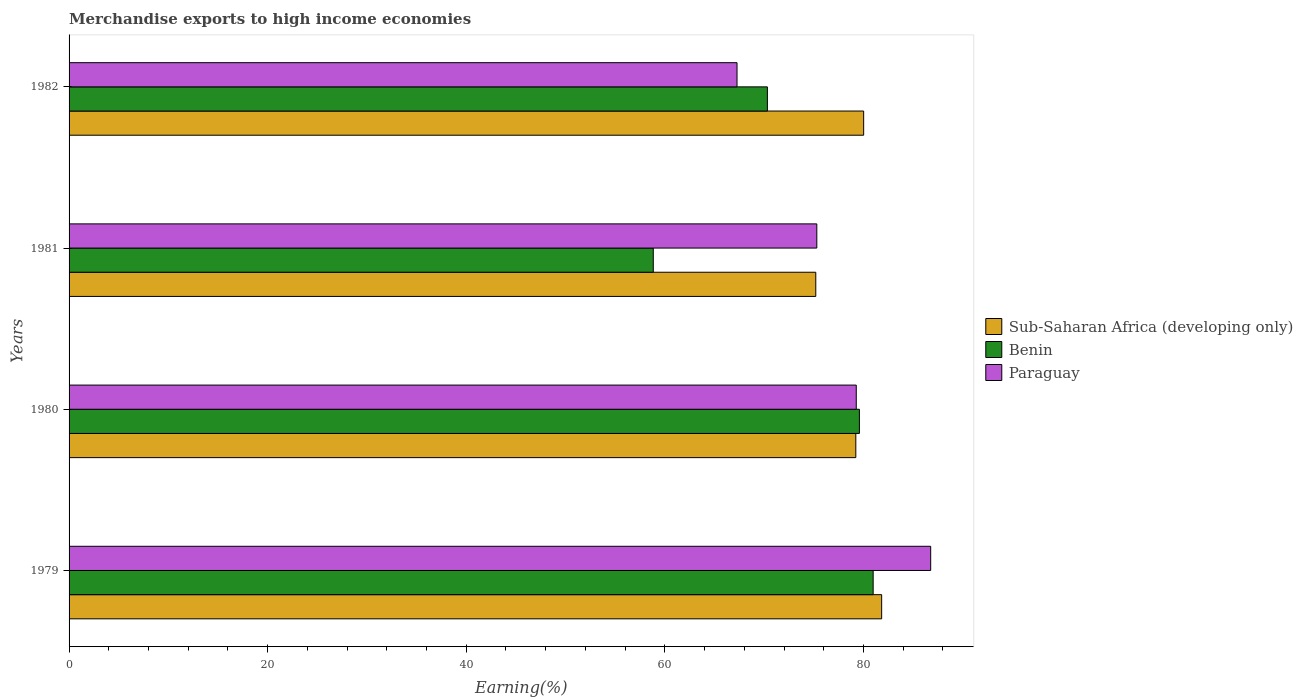Are the number of bars on each tick of the Y-axis equal?
Keep it short and to the point. Yes. How many bars are there on the 3rd tick from the top?
Give a very brief answer. 3. In how many cases, is the number of bars for a given year not equal to the number of legend labels?
Offer a terse response. 0. What is the percentage of amount earned from merchandise exports in Benin in 1982?
Your response must be concise. 70.33. Across all years, what is the maximum percentage of amount earned from merchandise exports in Paraguay?
Provide a short and direct response. 86.77. Across all years, what is the minimum percentage of amount earned from merchandise exports in Paraguay?
Ensure brevity in your answer.  67.27. In which year was the percentage of amount earned from merchandise exports in Sub-Saharan Africa (developing only) maximum?
Your answer should be very brief. 1979. In which year was the percentage of amount earned from merchandise exports in Sub-Saharan Africa (developing only) minimum?
Your response must be concise. 1981. What is the total percentage of amount earned from merchandise exports in Sub-Saharan Africa (developing only) in the graph?
Ensure brevity in your answer.  316.29. What is the difference between the percentage of amount earned from merchandise exports in Paraguay in 1979 and that in 1981?
Offer a terse response. 11.47. What is the difference between the percentage of amount earned from merchandise exports in Paraguay in 1981 and the percentage of amount earned from merchandise exports in Benin in 1982?
Make the answer very short. 4.98. What is the average percentage of amount earned from merchandise exports in Paraguay per year?
Provide a short and direct response. 77.16. In the year 1981, what is the difference between the percentage of amount earned from merchandise exports in Benin and percentage of amount earned from merchandise exports in Sub-Saharan Africa (developing only)?
Provide a short and direct response. -16.37. What is the ratio of the percentage of amount earned from merchandise exports in Paraguay in 1980 to that in 1981?
Your answer should be compact. 1.05. Is the difference between the percentage of amount earned from merchandise exports in Benin in 1979 and 1980 greater than the difference between the percentage of amount earned from merchandise exports in Sub-Saharan Africa (developing only) in 1979 and 1980?
Ensure brevity in your answer.  No. What is the difference between the highest and the second highest percentage of amount earned from merchandise exports in Paraguay?
Offer a terse response. 7.5. What is the difference between the highest and the lowest percentage of amount earned from merchandise exports in Paraguay?
Provide a short and direct response. 19.5. What does the 2nd bar from the top in 1980 represents?
Your response must be concise. Benin. What does the 1st bar from the bottom in 1981 represents?
Your answer should be very brief. Sub-Saharan Africa (developing only). Is it the case that in every year, the sum of the percentage of amount earned from merchandise exports in Paraguay and percentage of amount earned from merchandise exports in Benin is greater than the percentage of amount earned from merchandise exports in Sub-Saharan Africa (developing only)?
Keep it short and to the point. Yes. How many years are there in the graph?
Your answer should be compact. 4. What is the difference between two consecutive major ticks on the X-axis?
Your answer should be very brief. 20. Does the graph contain any zero values?
Keep it short and to the point. No. Where does the legend appear in the graph?
Your response must be concise. Center right. How many legend labels are there?
Ensure brevity in your answer.  3. How are the legend labels stacked?
Your answer should be compact. Vertical. What is the title of the graph?
Provide a short and direct response. Merchandise exports to high income economies. Does "Nepal" appear as one of the legend labels in the graph?
Make the answer very short. No. What is the label or title of the X-axis?
Provide a succinct answer. Earning(%). What is the Earning(%) in Sub-Saharan Africa (developing only) in 1979?
Provide a succinct answer. 81.83. What is the Earning(%) of Benin in 1979?
Provide a succinct answer. 80.98. What is the Earning(%) in Paraguay in 1979?
Make the answer very short. 86.77. What is the Earning(%) of Sub-Saharan Africa (developing only) in 1980?
Make the answer very short. 79.23. What is the Earning(%) in Benin in 1980?
Keep it short and to the point. 79.59. What is the Earning(%) of Paraguay in 1980?
Your answer should be very brief. 79.28. What is the Earning(%) of Sub-Saharan Africa (developing only) in 1981?
Your response must be concise. 75.2. What is the Earning(%) in Benin in 1981?
Provide a succinct answer. 58.83. What is the Earning(%) in Paraguay in 1981?
Keep it short and to the point. 75.3. What is the Earning(%) in Sub-Saharan Africa (developing only) in 1982?
Keep it short and to the point. 80.02. What is the Earning(%) in Benin in 1982?
Offer a very short reply. 70.33. What is the Earning(%) in Paraguay in 1982?
Make the answer very short. 67.27. Across all years, what is the maximum Earning(%) of Sub-Saharan Africa (developing only)?
Your answer should be very brief. 81.83. Across all years, what is the maximum Earning(%) in Benin?
Ensure brevity in your answer.  80.98. Across all years, what is the maximum Earning(%) in Paraguay?
Your answer should be very brief. 86.77. Across all years, what is the minimum Earning(%) of Sub-Saharan Africa (developing only)?
Your answer should be very brief. 75.2. Across all years, what is the minimum Earning(%) in Benin?
Provide a short and direct response. 58.83. Across all years, what is the minimum Earning(%) of Paraguay?
Your response must be concise. 67.27. What is the total Earning(%) in Sub-Saharan Africa (developing only) in the graph?
Give a very brief answer. 316.29. What is the total Earning(%) in Benin in the graph?
Give a very brief answer. 289.73. What is the total Earning(%) of Paraguay in the graph?
Your answer should be very brief. 308.62. What is the difference between the Earning(%) of Sub-Saharan Africa (developing only) in 1979 and that in 1980?
Give a very brief answer. 2.6. What is the difference between the Earning(%) in Benin in 1979 and that in 1980?
Ensure brevity in your answer.  1.38. What is the difference between the Earning(%) of Paraguay in 1979 and that in 1980?
Make the answer very short. 7.5. What is the difference between the Earning(%) in Sub-Saharan Africa (developing only) in 1979 and that in 1981?
Your answer should be very brief. 6.63. What is the difference between the Earning(%) of Benin in 1979 and that in 1981?
Offer a terse response. 22.14. What is the difference between the Earning(%) in Paraguay in 1979 and that in 1981?
Your answer should be very brief. 11.47. What is the difference between the Earning(%) of Sub-Saharan Africa (developing only) in 1979 and that in 1982?
Ensure brevity in your answer.  1.81. What is the difference between the Earning(%) in Benin in 1979 and that in 1982?
Make the answer very short. 10.65. What is the difference between the Earning(%) in Paraguay in 1979 and that in 1982?
Provide a short and direct response. 19.5. What is the difference between the Earning(%) of Sub-Saharan Africa (developing only) in 1980 and that in 1981?
Provide a succinct answer. 4.03. What is the difference between the Earning(%) in Benin in 1980 and that in 1981?
Your response must be concise. 20.76. What is the difference between the Earning(%) of Paraguay in 1980 and that in 1981?
Your response must be concise. 3.97. What is the difference between the Earning(%) of Sub-Saharan Africa (developing only) in 1980 and that in 1982?
Your answer should be very brief. -0.79. What is the difference between the Earning(%) of Benin in 1980 and that in 1982?
Keep it short and to the point. 9.27. What is the difference between the Earning(%) of Paraguay in 1980 and that in 1982?
Provide a succinct answer. 12.01. What is the difference between the Earning(%) of Sub-Saharan Africa (developing only) in 1981 and that in 1982?
Keep it short and to the point. -4.82. What is the difference between the Earning(%) in Benin in 1981 and that in 1982?
Provide a short and direct response. -11.49. What is the difference between the Earning(%) in Paraguay in 1981 and that in 1982?
Your answer should be very brief. 8.03. What is the difference between the Earning(%) of Sub-Saharan Africa (developing only) in 1979 and the Earning(%) of Benin in 1980?
Give a very brief answer. 2.24. What is the difference between the Earning(%) of Sub-Saharan Africa (developing only) in 1979 and the Earning(%) of Paraguay in 1980?
Provide a short and direct response. 2.56. What is the difference between the Earning(%) in Benin in 1979 and the Earning(%) in Paraguay in 1980?
Provide a succinct answer. 1.7. What is the difference between the Earning(%) in Sub-Saharan Africa (developing only) in 1979 and the Earning(%) in Benin in 1981?
Offer a terse response. 23. What is the difference between the Earning(%) of Sub-Saharan Africa (developing only) in 1979 and the Earning(%) of Paraguay in 1981?
Your response must be concise. 6.53. What is the difference between the Earning(%) in Benin in 1979 and the Earning(%) in Paraguay in 1981?
Provide a short and direct response. 5.67. What is the difference between the Earning(%) in Sub-Saharan Africa (developing only) in 1979 and the Earning(%) in Benin in 1982?
Offer a very short reply. 11.51. What is the difference between the Earning(%) of Sub-Saharan Africa (developing only) in 1979 and the Earning(%) of Paraguay in 1982?
Your answer should be compact. 14.57. What is the difference between the Earning(%) in Benin in 1979 and the Earning(%) in Paraguay in 1982?
Give a very brief answer. 13.71. What is the difference between the Earning(%) in Sub-Saharan Africa (developing only) in 1980 and the Earning(%) in Benin in 1981?
Your answer should be very brief. 20.4. What is the difference between the Earning(%) of Sub-Saharan Africa (developing only) in 1980 and the Earning(%) of Paraguay in 1981?
Provide a short and direct response. 3.93. What is the difference between the Earning(%) in Benin in 1980 and the Earning(%) in Paraguay in 1981?
Your answer should be very brief. 4.29. What is the difference between the Earning(%) in Sub-Saharan Africa (developing only) in 1980 and the Earning(%) in Benin in 1982?
Offer a very short reply. 8.9. What is the difference between the Earning(%) in Sub-Saharan Africa (developing only) in 1980 and the Earning(%) in Paraguay in 1982?
Make the answer very short. 11.96. What is the difference between the Earning(%) of Benin in 1980 and the Earning(%) of Paraguay in 1982?
Ensure brevity in your answer.  12.33. What is the difference between the Earning(%) in Sub-Saharan Africa (developing only) in 1981 and the Earning(%) in Benin in 1982?
Make the answer very short. 4.87. What is the difference between the Earning(%) in Sub-Saharan Africa (developing only) in 1981 and the Earning(%) in Paraguay in 1982?
Your answer should be very brief. 7.93. What is the difference between the Earning(%) of Benin in 1981 and the Earning(%) of Paraguay in 1982?
Provide a succinct answer. -8.43. What is the average Earning(%) in Sub-Saharan Africa (developing only) per year?
Give a very brief answer. 79.07. What is the average Earning(%) of Benin per year?
Ensure brevity in your answer.  72.43. What is the average Earning(%) in Paraguay per year?
Your response must be concise. 77.16. In the year 1979, what is the difference between the Earning(%) of Sub-Saharan Africa (developing only) and Earning(%) of Benin?
Your answer should be very brief. 0.86. In the year 1979, what is the difference between the Earning(%) in Sub-Saharan Africa (developing only) and Earning(%) in Paraguay?
Provide a short and direct response. -4.94. In the year 1979, what is the difference between the Earning(%) of Benin and Earning(%) of Paraguay?
Ensure brevity in your answer.  -5.79. In the year 1980, what is the difference between the Earning(%) of Sub-Saharan Africa (developing only) and Earning(%) of Benin?
Your response must be concise. -0.36. In the year 1980, what is the difference between the Earning(%) of Sub-Saharan Africa (developing only) and Earning(%) of Paraguay?
Make the answer very short. -0.05. In the year 1980, what is the difference between the Earning(%) in Benin and Earning(%) in Paraguay?
Make the answer very short. 0.32. In the year 1981, what is the difference between the Earning(%) of Sub-Saharan Africa (developing only) and Earning(%) of Benin?
Ensure brevity in your answer.  16.37. In the year 1981, what is the difference between the Earning(%) in Sub-Saharan Africa (developing only) and Earning(%) in Paraguay?
Your answer should be very brief. -0.1. In the year 1981, what is the difference between the Earning(%) of Benin and Earning(%) of Paraguay?
Make the answer very short. -16.47. In the year 1982, what is the difference between the Earning(%) in Sub-Saharan Africa (developing only) and Earning(%) in Benin?
Make the answer very short. 9.69. In the year 1982, what is the difference between the Earning(%) of Sub-Saharan Africa (developing only) and Earning(%) of Paraguay?
Provide a succinct answer. 12.75. In the year 1982, what is the difference between the Earning(%) of Benin and Earning(%) of Paraguay?
Keep it short and to the point. 3.06. What is the ratio of the Earning(%) of Sub-Saharan Africa (developing only) in 1979 to that in 1980?
Offer a terse response. 1.03. What is the ratio of the Earning(%) of Benin in 1979 to that in 1980?
Your answer should be compact. 1.02. What is the ratio of the Earning(%) in Paraguay in 1979 to that in 1980?
Provide a short and direct response. 1.09. What is the ratio of the Earning(%) in Sub-Saharan Africa (developing only) in 1979 to that in 1981?
Make the answer very short. 1.09. What is the ratio of the Earning(%) of Benin in 1979 to that in 1981?
Provide a short and direct response. 1.38. What is the ratio of the Earning(%) of Paraguay in 1979 to that in 1981?
Offer a terse response. 1.15. What is the ratio of the Earning(%) of Sub-Saharan Africa (developing only) in 1979 to that in 1982?
Make the answer very short. 1.02. What is the ratio of the Earning(%) of Benin in 1979 to that in 1982?
Offer a very short reply. 1.15. What is the ratio of the Earning(%) of Paraguay in 1979 to that in 1982?
Ensure brevity in your answer.  1.29. What is the ratio of the Earning(%) in Sub-Saharan Africa (developing only) in 1980 to that in 1981?
Your response must be concise. 1.05. What is the ratio of the Earning(%) in Benin in 1980 to that in 1981?
Make the answer very short. 1.35. What is the ratio of the Earning(%) in Paraguay in 1980 to that in 1981?
Offer a very short reply. 1.05. What is the ratio of the Earning(%) of Sub-Saharan Africa (developing only) in 1980 to that in 1982?
Your answer should be compact. 0.99. What is the ratio of the Earning(%) in Benin in 1980 to that in 1982?
Give a very brief answer. 1.13. What is the ratio of the Earning(%) of Paraguay in 1980 to that in 1982?
Ensure brevity in your answer.  1.18. What is the ratio of the Earning(%) in Sub-Saharan Africa (developing only) in 1981 to that in 1982?
Ensure brevity in your answer.  0.94. What is the ratio of the Earning(%) of Benin in 1981 to that in 1982?
Your answer should be very brief. 0.84. What is the ratio of the Earning(%) of Paraguay in 1981 to that in 1982?
Offer a very short reply. 1.12. What is the difference between the highest and the second highest Earning(%) in Sub-Saharan Africa (developing only)?
Your response must be concise. 1.81. What is the difference between the highest and the second highest Earning(%) of Benin?
Offer a terse response. 1.38. What is the difference between the highest and the second highest Earning(%) of Paraguay?
Provide a succinct answer. 7.5. What is the difference between the highest and the lowest Earning(%) of Sub-Saharan Africa (developing only)?
Ensure brevity in your answer.  6.63. What is the difference between the highest and the lowest Earning(%) of Benin?
Provide a short and direct response. 22.14. What is the difference between the highest and the lowest Earning(%) in Paraguay?
Keep it short and to the point. 19.5. 